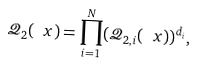<formula> <loc_0><loc_0><loc_500><loc_500>\mathcal { Q } _ { 2 } ( \ x ) = \prod _ { i = 1 } ^ { N } ( \mathcal { Q } _ { 2 , i } ( \ x ) ) ^ { d _ { i } } ,</formula> 